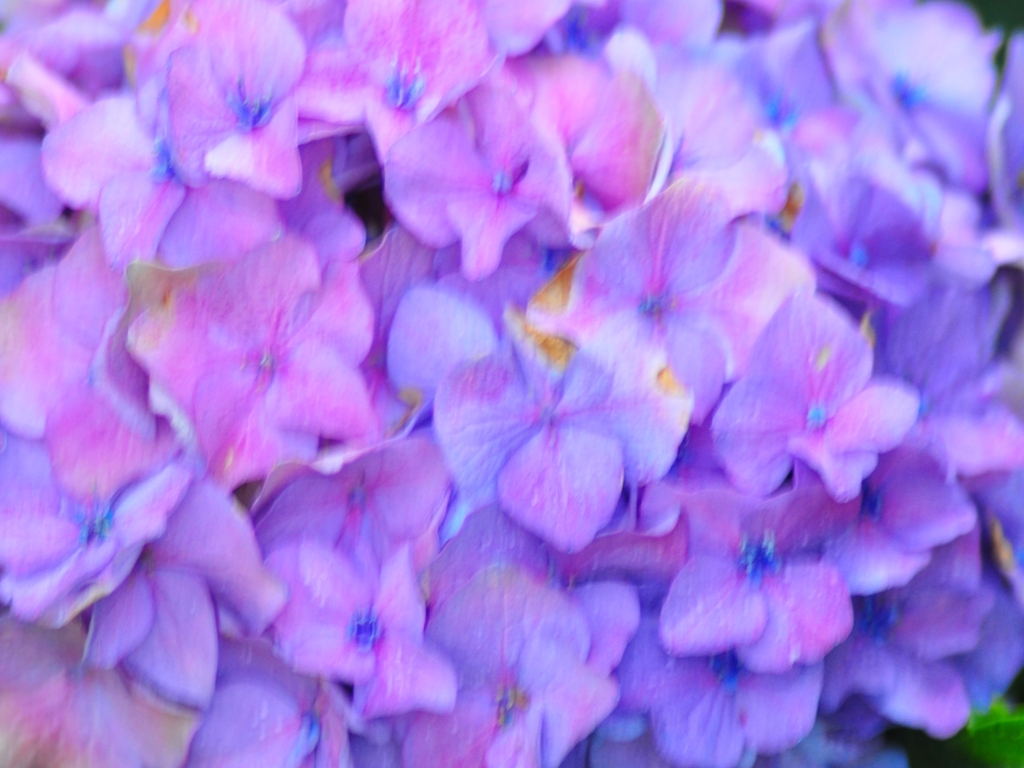Can you describe the mood or atmosphere that this image might evoke? The image evokes a sense of tranquility and softness, potentially resonating with feelings of calmness and reflection given the blend of soothing and cool colors, alongside the natural beauty of the blooms. 